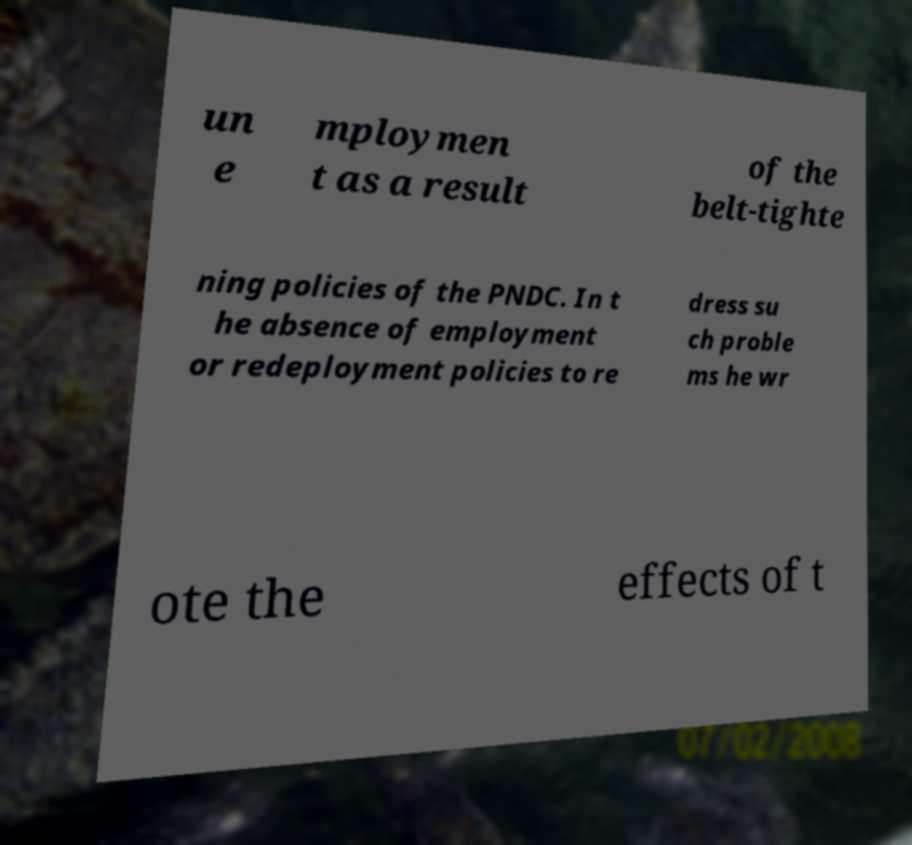Could you assist in decoding the text presented in this image and type it out clearly? un e mploymen t as a result of the belt-tighte ning policies of the PNDC. In t he absence of employment or redeployment policies to re dress su ch proble ms he wr ote the effects of t 